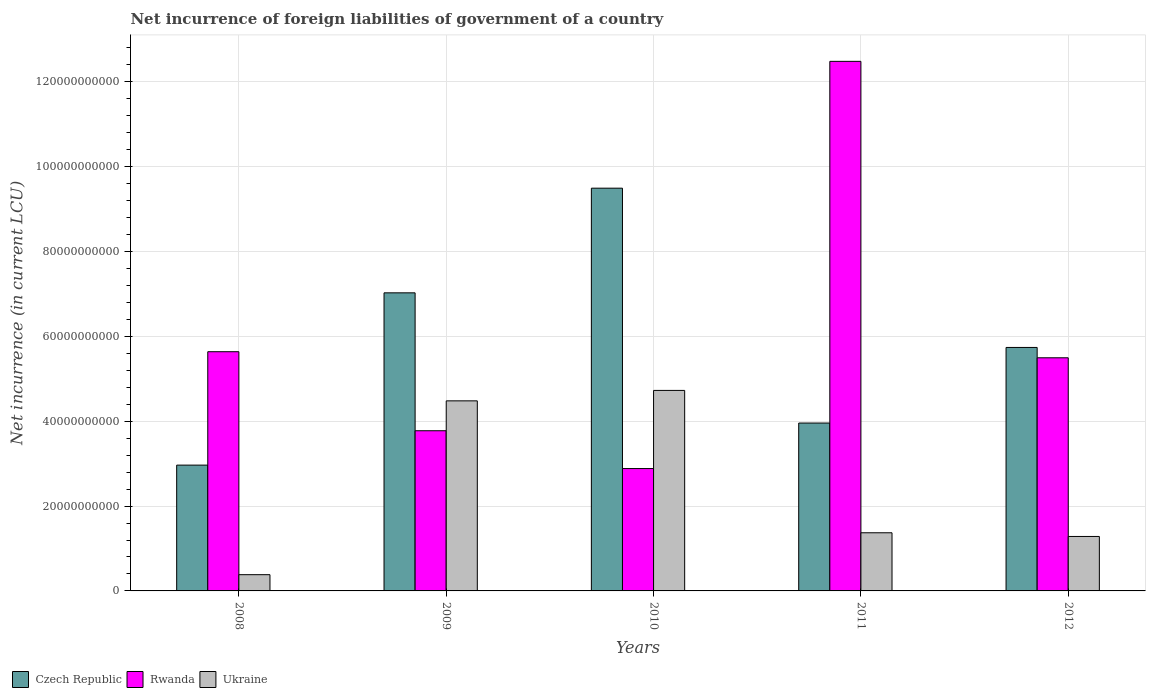How many bars are there on the 1st tick from the left?
Make the answer very short. 3. How many bars are there on the 2nd tick from the right?
Ensure brevity in your answer.  3. In how many cases, is the number of bars for a given year not equal to the number of legend labels?
Offer a very short reply. 0. What is the net incurrence of foreign liabilities in Czech Republic in 2011?
Your answer should be compact. 3.96e+1. Across all years, what is the maximum net incurrence of foreign liabilities in Rwanda?
Provide a short and direct response. 1.25e+11. Across all years, what is the minimum net incurrence of foreign liabilities in Czech Republic?
Ensure brevity in your answer.  2.96e+1. In which year was the net incurrence of foreign liabilities in Rwanda minimum?
Your answer should be very brief. 2010. What is the total net incurrence of foreign liabilities in Rwanda in the graph?
Give a very brief answer. 3.03e+11. What is the difference between the net incurrence of foreign liabilities in Rwanda in 2008 and that in 2010?
Provide a succinct answer. 2.75e+1. What is the difference between the net incurrence of foreign liabilities in Ukraine in 2008 and the net incurrence of foreign liabilities in Czech Republic in 2010?
Keep it short and to the point. -9.11e+1. What is the average net incurrence of foreign liabilities in Rwanda per year?
Your answer should be compact. 6.05e+1. In the year 2008, what is the difference between the net incurrence of foreign liabilities in Czech Republic and net incurrence of foreign liabilities in Rwanda?
Keep it short and to the point. -2.67e+1. In how many years, is the net incurrence of foreign liabilities in Ukraine greater than 12000000000 LCU?
Ensure brevity in your answer.  4. What is the ratio of the net incurrence of foreign liabilities in Rwanda in 2011 to that in 2012?
Ensure brevity in your answer.  2.27. Is the difference between the net incurrence of foreign liabilities in Czech Republic in 2008 and 2012 greater than the difference between the net incurrence of foreign liabilities in Rwanda in 2008 and 2012?
Provide a short and direct response. No. What is the difference between the highest and the second highest net incurrence of foreign liabilities in Rwanda?
Your answer should be compact. 6.84e+1. What is the difference between the highest and the lowest net incurrence of foreign liabilities in Czech Republic?
Your answer should be very brief. 6.53e+1. In how many years, is the net incurrence of foreign liabilities in Ukraine greater than the average net incurrence of foreign liabilities in Ukraine taken over all years?
Offer a very short reply. 2. What does the 3rd bar from the left in 2010 represents?
Your answer should be compact. Ukraine. What does the 1st bar from the right in 2010 represents?
Ensure brevity in your answer.  Ukraine. Are the values on the major ticks of Y-axis written in scientific E-notation?
Provide a succinct answer. No. Does the graph contain any zero values?
Ensure brevity in your answer.  No. What is the title of the graph?
Your response must be concise. Net incurrence of foreign liabilities of government of a country. Does "Greece" appear as one of the legend labels in the graph?
Provide a short and direct response. No. What is the label or title of the X-axis?
Provide a succinct answer. Years. What is the label or title of the Y-axis?
Offer a terse response. Net incurrence (in current LCU). What is the Net incurrence (in current LCU) in Czech Republic in 2008?
Give a very brief answer. 2.96e+1. What is the Net incurrence (in current LCU) of Rwanda in 2008?
Offer a very short reply. 5.64e+1. What is the Net incurrence (in current LCU) in Ukraine in 2008?
Give a very brief answer. 3.83e+09. What is the Net incurrence (in current LCU) in Czech Republic in 2009?
Your answer should be very brief. 7.03e+1. What is the Net incurrence (in current LCU) in Rwanda in 2009?
Offer a very short reply. 3.78e+1. What is the Net incurrence (in current LCU) of Ukraine in 2009?
Your answer should be very brief. 4.48e+1. What is the Net incurrence (in current LCU) in Czech Republic in 2010?
Offer a very short reply. 9.49e+1. What is the Net incurrence (in current LCU) of Rwanda in 2010?
Provide a short and direct response. 2.88e+1. What is the Net incurrence (in current LCU) of Ukraine in 2010?
Provide a short and direct response. 4.73e+1. What is the Net incurrence (in current LCU) in Czech Republic in 2011?
Ensure brevity in your answer.  3.96e+1. What is the Net incurrence (in current LCU) of Rwanda in 2011?
Offer a very short reply. 1.25e+11. What is the Net incurrence (in current LCU) of Ukraine in 2011?
Your answer should be compact. 1.37e+1. What is the Net incurrence (in current LCU) of Czech Republic in 2012?
Keep it short and to the point. 5.74e+1. What is the Net incurrence (in current LCU) in Rwanda in 2012?
Offer a terse response. 5.49e+1. What is the Net incurrence (in current LCU) in Ukraine in 2012?
Your answer should be compact. 1.28e+1. Across all years, what is the maximum Net incurrence (in current LCU) in Czech Republic?
Offer a very short reply. 9.49e+1. Across all years, what is the maximum Net incurrence (in current LCU) in Rwanda?
Your answer should be very brief. 1.25e+11. Across all years, what is the maximum Net incurrence (in current LCU) of Ukraine?
Your response must be concise. 4.73e+1. Across all years, what is the minimum Net incurrence (in current LCU) in Czech Republic?
Provide a succinct answer. 2.96e+1. Across all years, what is the minimum Net incurrence (in current LCU) of Rwanda?
Keep it short and to the point. 2.88e+1. Across all years, what is the minimum Net incurrence (in current LCU) of Ukraine?
Offer a terse response. 3.83e+09. What is the total Net incurrence (in current LCU) of Czech Republic in the graph?
Your answer should be compact. 2.92e+11. What is the total Net incurrence (in current LCU) of Rwanda in the graph?
Provide a succinct answer. 3.03e+11. What is the total Net incurrence (in current LCU) in Ukraine in the graph?
Ensure brevity in your answer.  1.22e+11. What is the difference between the Net incurrence (in current LCU) in Czech Republic in 2008 and that in 2009?
Your response must be concise. -4.06e+1. What is the difference between the Net incurrence (in current LCU) in Rwanda in 2008 and that in 2009?
Offer a very short reply. 1.86e+1. What is the difference between the Net incurrence (in current LCU) of Ukraine in 2008 and that in 2009?
Keep it short and to the point. -4.10e+1. What is the difference between the Net incurrence (in current LCU) in Czech Republic in 2008 and that in 2010?
Make the answer very short. -6.53e+1. What is the difference between the Net incurrence (in current LCU) in Rwanda in 2008 and that in 2010?
Offer a very short reply. 2.75e+1. What is the difference between the Net incurrence (in current LCU) of Ukraine in 2008 and that in 2010?
Give a very brief answer. -4.34e+1. What is the difference between the Net incurrence (in current LCU) in Czech Republic in 2008 and that in 2011?
Make the answer very short. -9.92e+09. What is the difference between the Net incurrence (in current LCU) of Rwanda in 2008 and that in 2011?
Provide a short and direct response. -6.84e+1. What is the difference between the Net incurrence (in current LCU) in Ukraine in 2008 and that in 2011?
Offer a very short reply. -9.88e+09. What is the difference between the Net incurrence (in current LCU) in Czech Republic in 2008 and that in 2012?
Ensure brevity in your answer.  -2.77e+1. What is the difference between the Net incurrence (in current LCU) in Rwanda in 2008 and that in 2012?
Your answer should be compact. 1.43e+09. What is the difference between the Net incurrence (in current LCU) of Ukraine in 2008 and that in 2012?
Offer a very short reply. -9.00e+09. What is the difference between the Net incurrence (in current LCU) of Czech Republic in 2009 and that in 2010?
Make the answer very short. -2.47e+1. What is the difference between the Net incurrence (in current LCU) in Rwanda in 2009 and that in 2010?
Provide a short and direct response. 8.91e+09. What is the difference between the Net incurrence (in current LCU) in Ukraine in 2009 and that in 2010?
Your answer should be compact. -2.46e+09. What is the difference between the Net incurrence (in current LCU) of Czech Republic in 2009 and that in 2011?
Ensure brevity in your answer.  3.07e+1. What is the difference between the Net incurrence (in current LCU) of Rwanda in 2009 and that in 2011?
Give a very brief answer. -8.71e+1. What is the difference between the Net incurrence (in current LCU) in Ukraine in 2009 and that in 2011?
Ensure brevity in your answer.  3.11e+1. What is the difference between the Net incurrence (in current LCU) in Czech Republic in 2009 and that in 2012?
Ensure brevity in your answer.  1.29e+1. What is the difference between the Net incurrence (in current LCU) of Rwanda in 2009 and that in 2012?
Your answer should be compact. -1.72e+1. What is the difference between the Net incurrence (in current LCU) of Ukraine in 2009 and that in 2012?
Ensure brevity in your answer.  3.20e+1. What is the difference between the Net incurrence (in current LCU) in Czech Republic in 2010 and that in 2011?
Offer a terse response. 5.54e+1. What is the difference between the Net incurrence (in current LCU) of Rwanda in 2010 and that in 2011?
Offer a very short reply. -9.60e+1. What is the difference between the Net incurrence (in current LCU) of Ukraine in 2010 and that in 2011?
Provide a short and direct response. 3.36e+1. What is the difference between the Net incurrence (in current LCU) in Czech Republic in 2010 and that in 2012?
Make the answer very short. 3.75e+1. What is the difference between the Net incurrence (in current LCU) in Rwanda in 2010 and that in 2012?
Your answer should be compact. -2.61e+1. What is the difference between the Net incurrence (in current LCU) in Ukraine in 2010 and that in 2012?
Keep it short and to the point. 3.44e+1. What is the difference between the Net incurrence (in current LCU) of Czech Republic in 2011 and that in 2012?
Give a very brief answer. -1.78e+1. What is the difference between the Net incurrence (in current LCU) in Rwanda in 2011 and that in 2012?
Your answer should be very brief. 6.99e+1. What is the difference between the Net incurrence (in current LCU) in Ukraine in 2011 and that in 2012?
Your response must be concise. 8.71e+08. What is the difference between the Net incurrence (in current LCU) in Czech Republic in 2008 and the Net incurrence (in current LCU) in Rwanda in 2009?
Your answer should be compact. -8.10e+09. What is the difference between the Net incurrence (in current LCU) in Czech Republic in 2008 and the Net incurrence (in current LCU) in Ukraine in 2009?
Offer a terse response. -1.51e+1. What is the difference between the Net incurrence (in current LCU) in Rwanda in 2008 and the Net incurrence (in current LCU) in Ukraine in 2009?
Offer a very short reply. 1.16e+1. What is the difference between the Net incurrence (in current LCU) of Czech Republic in 2008 and the Net incurrence (in current LCU) of Rwanda in 2010?
Your answer should be compact. 8.08e+08. What is the difference between the Net incurrence (in current LCU) in Czech Republic in 2008 and the Net incurrence (in current LCU) in Ukraine in 2010?
Give a very brief answer. -1.76e+1. What is the difference between the Net incurrence (in current LCU) of Rwanda in 2008 and the Net incurrence (in current LCU) of Ukraine in 2010?
Offer a very short reply. 9.12e+09. What is the difference between the Net incurrence (in current LCU) in Czech Republic in 2008 and the Net incurrence (in current LCU) in Rwanda in 2011?
Your answer should be very brief. -9.52e+1. What is the difference between the Net incurrence (in current LCU) in Czech Republic in 2008 and the Net incurrence (in current LCU) in Ukraine in 2011?
Offer a terse response. 1.59e+1. What is the difference between the Net incurrence (in current LCU) of Rwanda in 2008 and the Net incurrence (in current LCU) of Ukraine in 2011?
Provide a succinct answer. 4.27e+1. What is the difference between the Net incurrence (in current LCU) in Czech Republic in 2008 and the Net incurrence (in current LCU) in Rwanda in 2012?
Offer a terse response. -2.53e+1. What is the difference between the Net incurrence (in current LCU) in Czech Republic in 2008 and the Net incurrence (in current LCU) in Ukraine in 2012?
Offer a very short reply. 1.68e+1. What is the difference between the Net incurrence (in current LCU) of Rwanda in 2008 and the Net incurrence (in current LCU) of Ukraine in 2012?
Your answer should be very brief. 4.35e+1. What is the difference between the Net incurrence (in current LCU) in Czech Republic in 2009 and the Net incurrence (in current LCU) in Rwanda in 2010?
Ensure brevity in your answer.  4.14e+1. What is the difference between the Net incurrence (in current LCU) of Czech Republic in 2009 and the Net incurrence (in current LCU) of Ukraine in 2010?
Your answer should be very brief. 2.30e+1. What is the difference between the Net incurrence (in current LCU) of Rwanda in 2009 and the Net incurrence (in current LCU) of Ukraine in 2010?
Offer a terse response. -9.51e+09. What is the difference between the Net incurrence (in current LCU) of Czech Republic in 2009 and the Net incurrence (in current LCU) of Rwanda in 2011?
Provide a short and direct response. -5.46e+1. What is the difference between the Net incurrence (in current LCU) in Czech Republic in 2009 and the Net incurrence (in current LCU) in Ukraine in 2011?
Your answer should be compact. 5.66e+1. What is the difference between the Net incurrence (in current LCU) in Rwanda in 2009 and the Net incurrence (in current LCU) in Ukraine in 2011?
Your answer should be very brief. 2.40e+1. What is the difference between the Net incurrence (in current LCU) in Czech Republic in 2009 and the Net incurrence (in current LCU) in Rwanda in 2012?
Keep it short and to the point. 1.53e+1. What is the difference between the Net incurrence (in current LCU) in Czech Republic in 2009 and the Net incurrence (in current LCU) in Ukraine in 2012?
Your answer should be compact. 5.74e+1. What is the difference between the Net incurrence (in current LCU) in Rwanda in 2009 and the Net incurrence (in current LCU) in Ukraine in 2012?
Ensure brevity in your answer.  2.49e+1. What is the difference between the Net incurrence (in current LCU) in Czech Republic in 2010 and the Net incurrence (in current LCU) in Rwanda in 2011?
Your response must be concise. -2.99e+1. What is the difference between the Net incurrence (in current LCU) in Czech Republic in 2010 and the Net incurrence (in current LCU) in Ukraine in 2011?
Offer a terse response. 8.12e+1. What is the difference between the Net incurrence (in current LCU) in Rwanda in 2010 and the Net incurrence (in current LCU) in Ukraine in 2011?
Ensure brevity in your answer.  1.51e+1. What is the difference between the Net incurrence (in current LCU) in Czech Republic in 2010 and the Net incurrence (in current LCU) in Rwanda in 2012?
Provide a succinct answer. 4.00e+1. What is the difference between the Net incurrence (in current LCU) in Czech Republic in 2010 and the Net incurrence (in current LCU) in Ukraine in 2012?
Provide a succinct answer. 8.21e+1. What is the difference between the Net incurrence (in current LCU) in Rwanda in 2010 and the Net incurrence (in current LCU) in Ukraine in 2012?
Provide a short and direct response. 1.60e+1. What is the difference between the Net incurrence (in current LCU) of Czech Republic in 2011 and the Net incurrence (in current LCU) of Rwanda in 2012?
Your answer should be compact. -1.54e+1. What is the difference between the Net incurrence (in current LCU) of Czech Republic in 2011 and the Net incurrence (in current LCU) of Ukraine in 2012?
Keep it short and to the point. 2.67e+1. What is the difference between the Net incurrence (in current LCU) in Rwanda in 2011 and the Net incurrence (in current LCU) in Ukraine in 2012?
Your answer should be compact. 1.12e+11. What is the average Net incurrence (in current LCU) in Czech Republic per year?
Ensure brevity in your answer.  5.84e+1. What is the average Net incurrence (in current LCU) in Rwanda per year?
Your answer should be compact. 6.05e+1. What is the average Net incurrence (in current LCU) in Ukraine per year?
Ensure brevity in your answer.  2.45e+1. In the year 2008, what is the difference between the Net incurrence (in current LCU) in Czech Republic and Net incurrence (in current LCU) in Rwanda?
Keep it short and to the point. -2.67e+1. In the year 2008, what is the difference between the Net incurrence (in current LCU) in Czech Republic and Net incurrence (in current LCU) in Ukraine?
Ensure brevity in your answer.  2.58e+1. In the year 2008, what is the difference between the Net incurrence (in current LCU) in Rwanda and Net incurrence (in current LCU) in Ukraine?
Keep it short and to the point. 5.26e+1. In the year 2009, what is the difference between the Net incurrence (in current LCU) of Czech Republic and Net incurrence (in current LCU) of Rwanda?
Give a very brief answer. 3.25e+1. In the year 2009, what is the difference between the Net incurrence (in current LCU) in Czech Republic and Net incurrence (in current LCU) in Ukraine?
Your answer should be very brief. 2.55e+1. In the year 2009, what is the difference between the Net incurrence (in current LCU) of Rwanda and Net incurrence (in current LCU) of Ukraine?
Provide a succinct answer. -7.05e+09. In the year 2010, what is the difference between the Net incurrence (in current LCU) of Czech Republic and Net incurrence (in current LCU) of Rwanda?
Offer a very short reply. 6.61e+1. In the year 2010, what is the difference between the Net incurrence (in current LCU) of Czech Republic and Net incurrence (in current LCU) of Ukraine?
Offer a terse response. 4.77e+1. In the year 2010, what is the difference between the Net incurrence (in current LCU) of Rwanda and Net incurrence (in current LCU) of Ukraine?
Offer a terse response. -1.84e+1. In the year 2011, what is the difference between the Net incurrence (in current LCU) of Czech Republic and Net incurrence (in current LCU) of Rwanda?
Give a very brief answer. -8.52e+1. In the year 2011, what is the difference between the Net incurrence (in current LCU) of Czech Republic and Net incurrence (in current LCU) of Ukraine?
Make the answer very short. 2.59e+1. In the year 2011, what is the difference between the Net incurrence (in current LCU) in Rwanda and Net incurrence (in current LCU) in Ukraine?
Offer a very short reply. 1.11e+11. In the year 2012, what is the difference between the Net incurrence (in current LCU) in Czech Republic and Net incurrence (in current LCU) in Rwanda?
Provide a short and direct response. 2.43e+09. In the year 2012, what is the difference between the Net incurrence (in current LCU) of Czech Republic and Net incurrence (in current LCU) of Ukraine?
Offer a very short reply. 4.45e+1. In the year 2012, what is the difference between the Net incurrence (in current LCU) in Rwanda and Net incurrence (in current LCU) in Ukraine?
Your response must be concise. 4.21e+1. What is the ratio of the Net incurrence (in current LCU) of Czech Republic in 2008 to that in 2009?
Offer a terse response. 0.42. What is the ratio of the Net incurrence (in current LCU) of Rwanda in 2008 to that in 2009?
Your answer should be compact. 1.49. What is the ratio of the Net incurrence (in current LCU) of Ukraine in 2008 to that in 2009?
Offer a terse response. 0.09. What is the ratio of the Net incurrence (in current LCU) in Czech Republic in 2008 to that in 2010?
Offer a terse response. 0.31. What is the ratio of the Net incurrence (in current LCU) in Rwanda in 2008 to that in 2010?
Provide a succinct answer. 1.95. What is the ratio of the Net incurrence (in current LCU) of Ukraine in 2008 to that in 2010?
Give a very brief answer. 0.08. What is the ratio of the Net incurrence (in current LCU) of Czech Republic in 2008 to that in 2011?
Your answer should be very brief. 0.75. What is the ratio of the Net incurrence (in current LCU) of Rwanda in 2008 to that in 2011?
Make the answer very short. 0.45. What is the ratio of the Net incurrence (in current LCU) of Ukraine in 2008 to that in 2011?
Provide a short and direct response. 0.28. What is the ratio of the Net incurrence (in current LCU) in Czech Republic in 2008 to that in 2012?
Ensure brevity in your answer.  0.52. What is the ratio of the Net incurrence (in current LCU) in Ukraine in 2008 to that in 2012?
Keep it short and to the point. 0.3. What is the ratio of the Net incurrence (in current LCU) in Czech Republic in 2009 to that in 2010?
Offer a terse response. 0.74. What is the ratio of the Net incurrence (in current LCU) of Rwanda in 2009 to that in 2010?
Your response must be concise. 1.31. What is the ratio of the Net incurrence (in current LCU) of Ukraine in 2009 to that in 2010?
Offer a terse response. 0.95. What is the ratio of the Net incurrence (in current LCU) in Czech Republic in 2009 to that in 2011?
Provide a succinct answer. 1.78. What is the ratio of the Net incurrence (in current LCU) in Rwanda in 2009 to that in 2011?
Keep it short and to the point. 0.3. What is the ratio of the Net incurrence (in current LCU) in Ukraine in 2009 to that in 2011?
Offer a very short reply. 3.27. What is the ratio of the Net incurrence (in current LCU) of Czech Republic in 2009 to that in 2012?
Give a very brief answer. 1.22. What is the ratio of the Net incurrence (in current LCU) of Rwanda in 2009 to that in 2012?
Keep it short and to the point. 0.69. What is the ratio of the Net incurrence (in current LCU) in Ukraine in 2009 to that in 2012?
Make the answer very short. 3.49. What is the ratio of the Net incurrence (in current LCU) of Czech Republic in 2010 to that in 2011?
Provide a succinct answer. 2.4. What is the ratio of the Net incurrence (in current LCU) in Rwanda in 2010 to that in 2011?
Give a very brief answer. 0.23. What is the ratio of the Net incurrence (in current LCU) of Ukraine in 2010 to that in 2011?
Your response must be concise. 3.45. What is the ratio of the Net incurrence (in current LCU) of Czech Republic in 2010 to that in 2012?
Make the answer very short. 1.65. What is the ratio of the Net incurrence (in current LCU) of Rwanda in 2010 to that in 2012?
Give a very brief answer. 0.52. What is the ratio of the Net incurrence (in current LCU) of Ukraine in 2010 to that in 2012?
Your answer should be very brief. 3.68. What is the ratio of the Net incurrence (in current LCU) of Czech Republic in 2011 to that in 2012?
Ensure brevity in your answer.  0.69. What is the ratio of the Net incurrence (in current LCU) of Rwanda in 2011 to that in 2012?
Give a very brief answer. 2.27. What is the ratio of the Net incurrence (in current LCU) in Ukraine in 2011 to that in 2012?
Your response must be concise. 1.07. What is the difference between the highest and the second highest Net incurrence (in current LCU) in Czech Republic?
Keep it short and to the point. 2.47e+1. What is the difference between the highest and the second highest Net incurrence (in current LCU) of Rwanda?
Offer a terse response. 6.84e+1. What is the difference between the highest and the second highest Net incurrence (in current LCU) in Ukraine?
Your response must be concise. 2.46e+09. What is the difference between the highest and the lowest Net incurrence (in current LCU) in Czech Republic?
Offer a very short reply. 6.53e+1. What is the difference between the highest and the lowest Net incurrence (in current LCU) in Rwanda?
Ensure brevity in your answer.  9.60e+1. What is the difference between the highest and the lowest Net incurrence (in current LCU) of Ukraine?
Keep it short and to the point. 4.34e+1. 